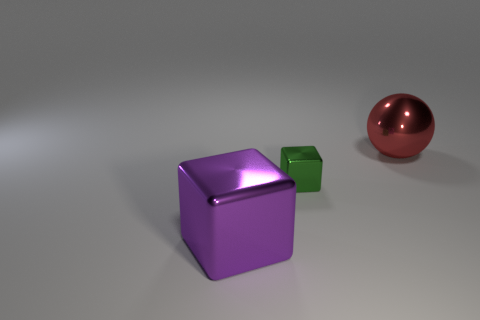What materials do these objects look like they're made of? The objects appear to be rendered with different materials. The purple and green cubes seem to have a matte surface that might mimic a plastic texture, while the red sphere has a shiny, reflective surface indicative of a polished metal finish. 